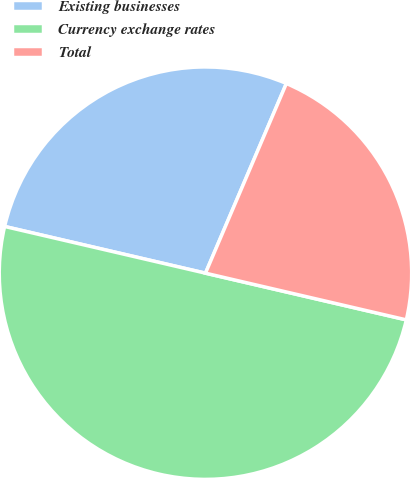Convert chart. <chart><loc_0><loc_0><loc_500><loc_500><pie_chart><fcel>Existing businesses<fcel>Currency exchange rates<fcel>Total<nl><fcel>27.78%<fcel>50.0%<fcel>22.22%<nl></chart> 